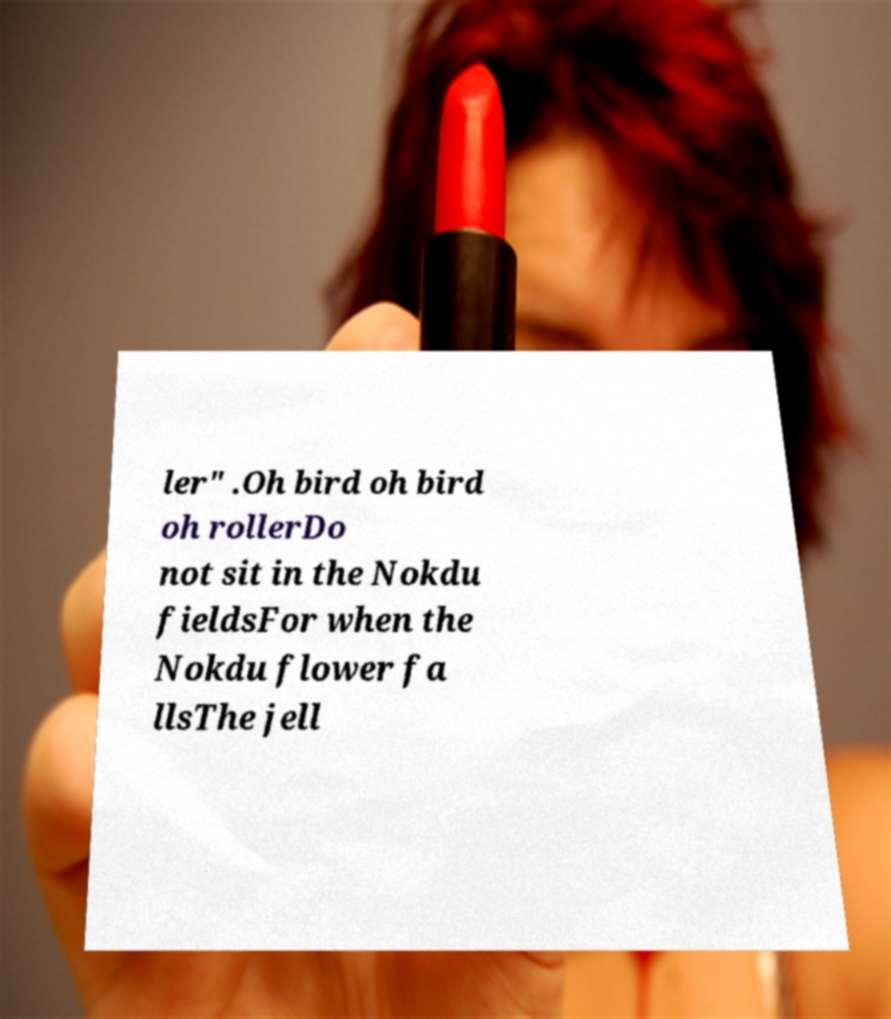Could you extract and type out the text from this image? ler" .Oh bird oh bird oh rollerDo not sit in the Nokdu fieldsFor when the Nokdu flower fa llsThe jell 